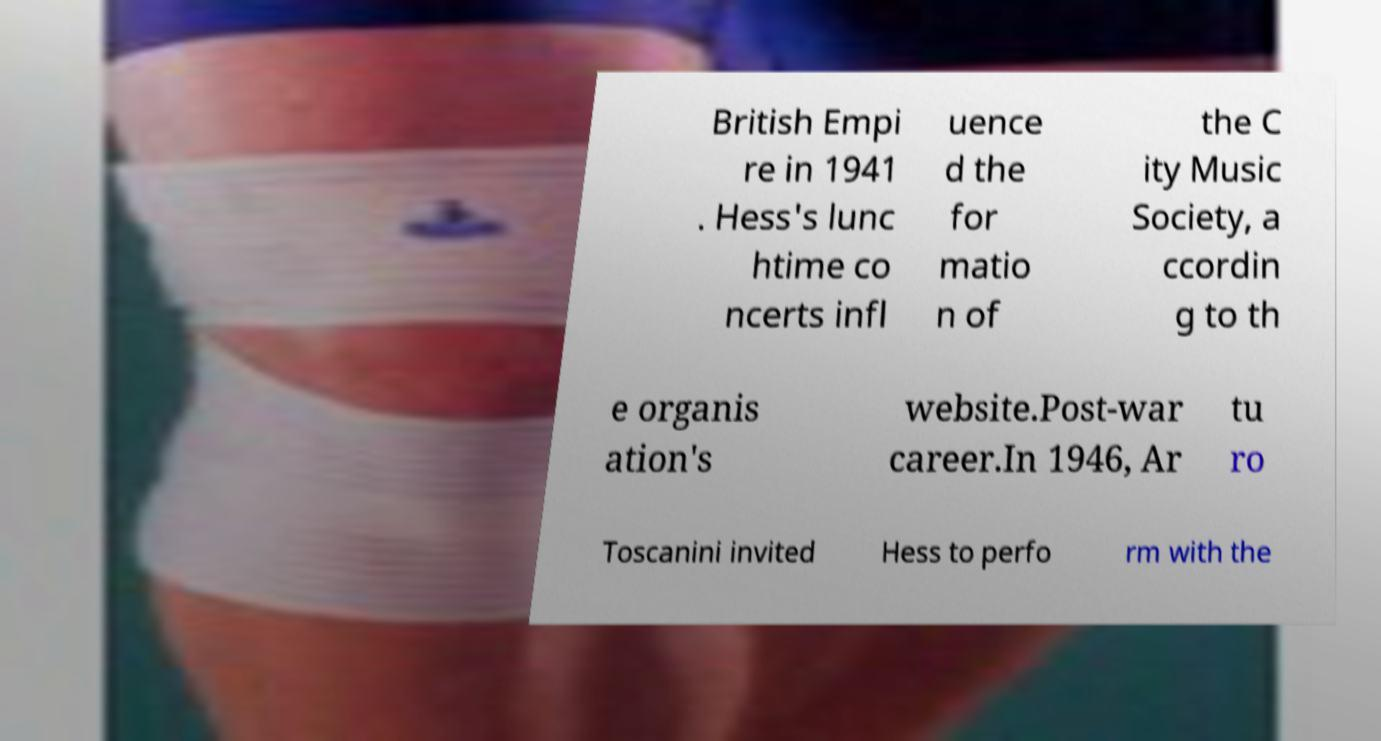Please read and relay the text visible in this image. What does it say? British Empi re in 1941 . Hess's lunc htime co ncerts infl uence d the for matio n of the C ity Music Society, a ccordin g to th e organis ation's website.Post-war career.In 1946, Ar tu ro Toscanini invited Hess to perfo rm with the 